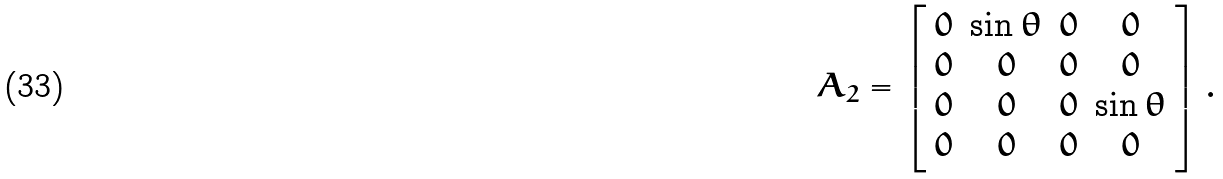Convert formula to latex. <formula><loc_0><loc_0><loc_500><loc_500>A _ { 2 } = \left [ \begin{array} { c c c c } 0 & \sin \theta & 0 & 0 \\ 0 & 0 & 0 & 0 \\ 0 & 0 & 0 & \sin \theta \\ 0 & 0 & 0 & 0 \end{array} \right ] .</formula> 